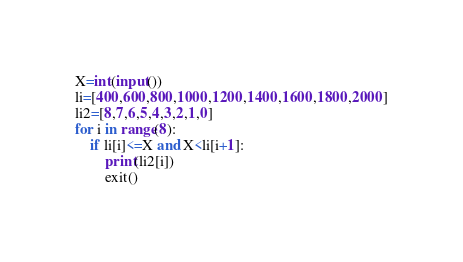Convert code to text. <code><loc_0><loc_0><loc_500><loc_500><_Python_>X=int(input())
li=[400,600,800,1000,1200,1400,1600,1800,2000]
li2=[8,7,6,5,4,3,2,1,0]
for i in range(8):
    if li[i]<=X and X<li[i+1]:
        print(li2[i])
        exit()</code> 